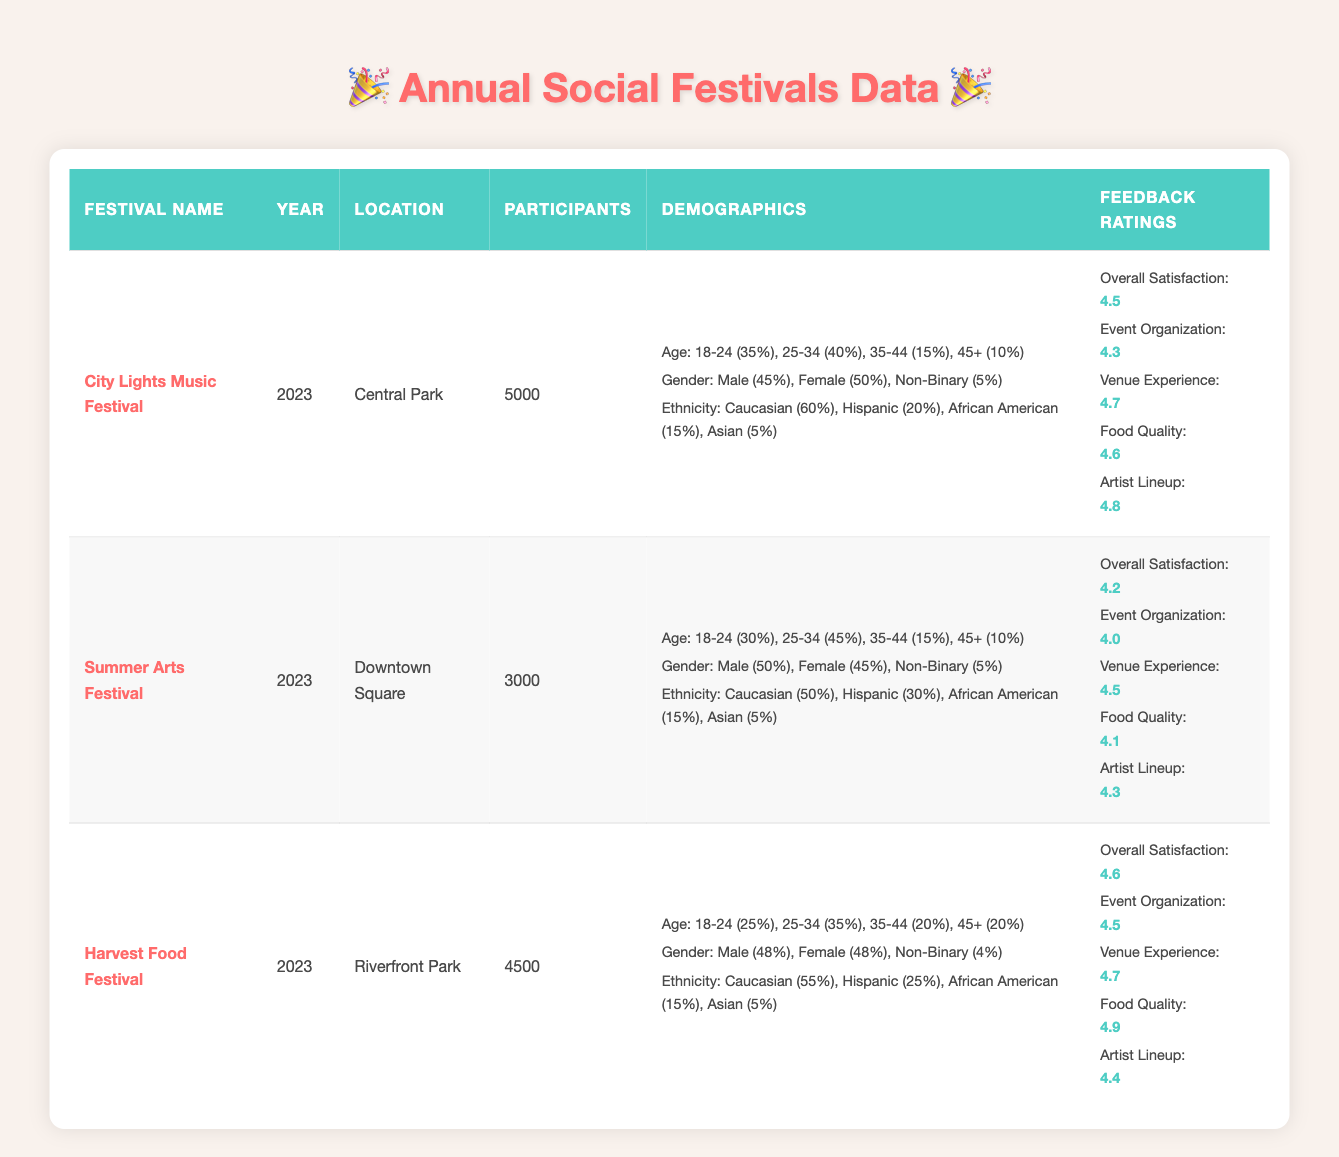What is the location of the City Lights Music Festival? The table lists the location of the City Lights Music Festival as "Central Park."
Answer: Central Park How many participants attended the Harvest Food Festival? According to the table, the number of participants for the Harvest Food Festival is 4500.
Answer: 4500 Which festival had the highest feedback rating for Artist Lineup? The Artist Lineup rating for the City Lights Music Festival is 4.8, which is higher than the ratings for the other festivals (4.3 for Summer Arts Festival and 4.4 for Harvest Food Festival).
Answer: City Lights Music Festival What is the percentage of participants aged 35-44 in the Summer Arts Festival? The demographics section for the Summer Arts Festival indicates that 15% of the participants are aged 35-44.
Answer: 15% Which festival had more male participants, City Lights Music Festival or Harvest Food Festival? City Lights Music Festival has 45% male participants, while Harvest Food Festival has 48% male participants, making Harvest the festival with a higher percentage of male participants.
Answer: Harvest Food Festival What is the average overall satisfaction rating across all three festivals? The overall satisfaction ratings are 4.5 for City Lights, 4.2 for Summer Arts, and 4.6 for Harvest Food Festival. To find the average, sum them up (4.5 + 4.2 + 4.6 = 13.3) and divide by the number of festivals (13.3 / 3 = 4.4333), which rounds to 4.43.
Answer: 4.43 Are there more Hispanic participants in the Summer Arts Festival or the Harvest Food Festival? The data shows that the Summer Arts Festival has 30% Hispanic participants and the Harvest Food Festival has 25%. Therefore, the Summer Arts Festival has a higher percentage.
Answer: Yes What is the difference in participant count between City Lights Music Festival and Summer Arts Festival? City Lights Music Festival has 5000 participants and Summer Arts Festival has 3000. The difference is 5000 - 3000 = 2000.
Answer: 2000 